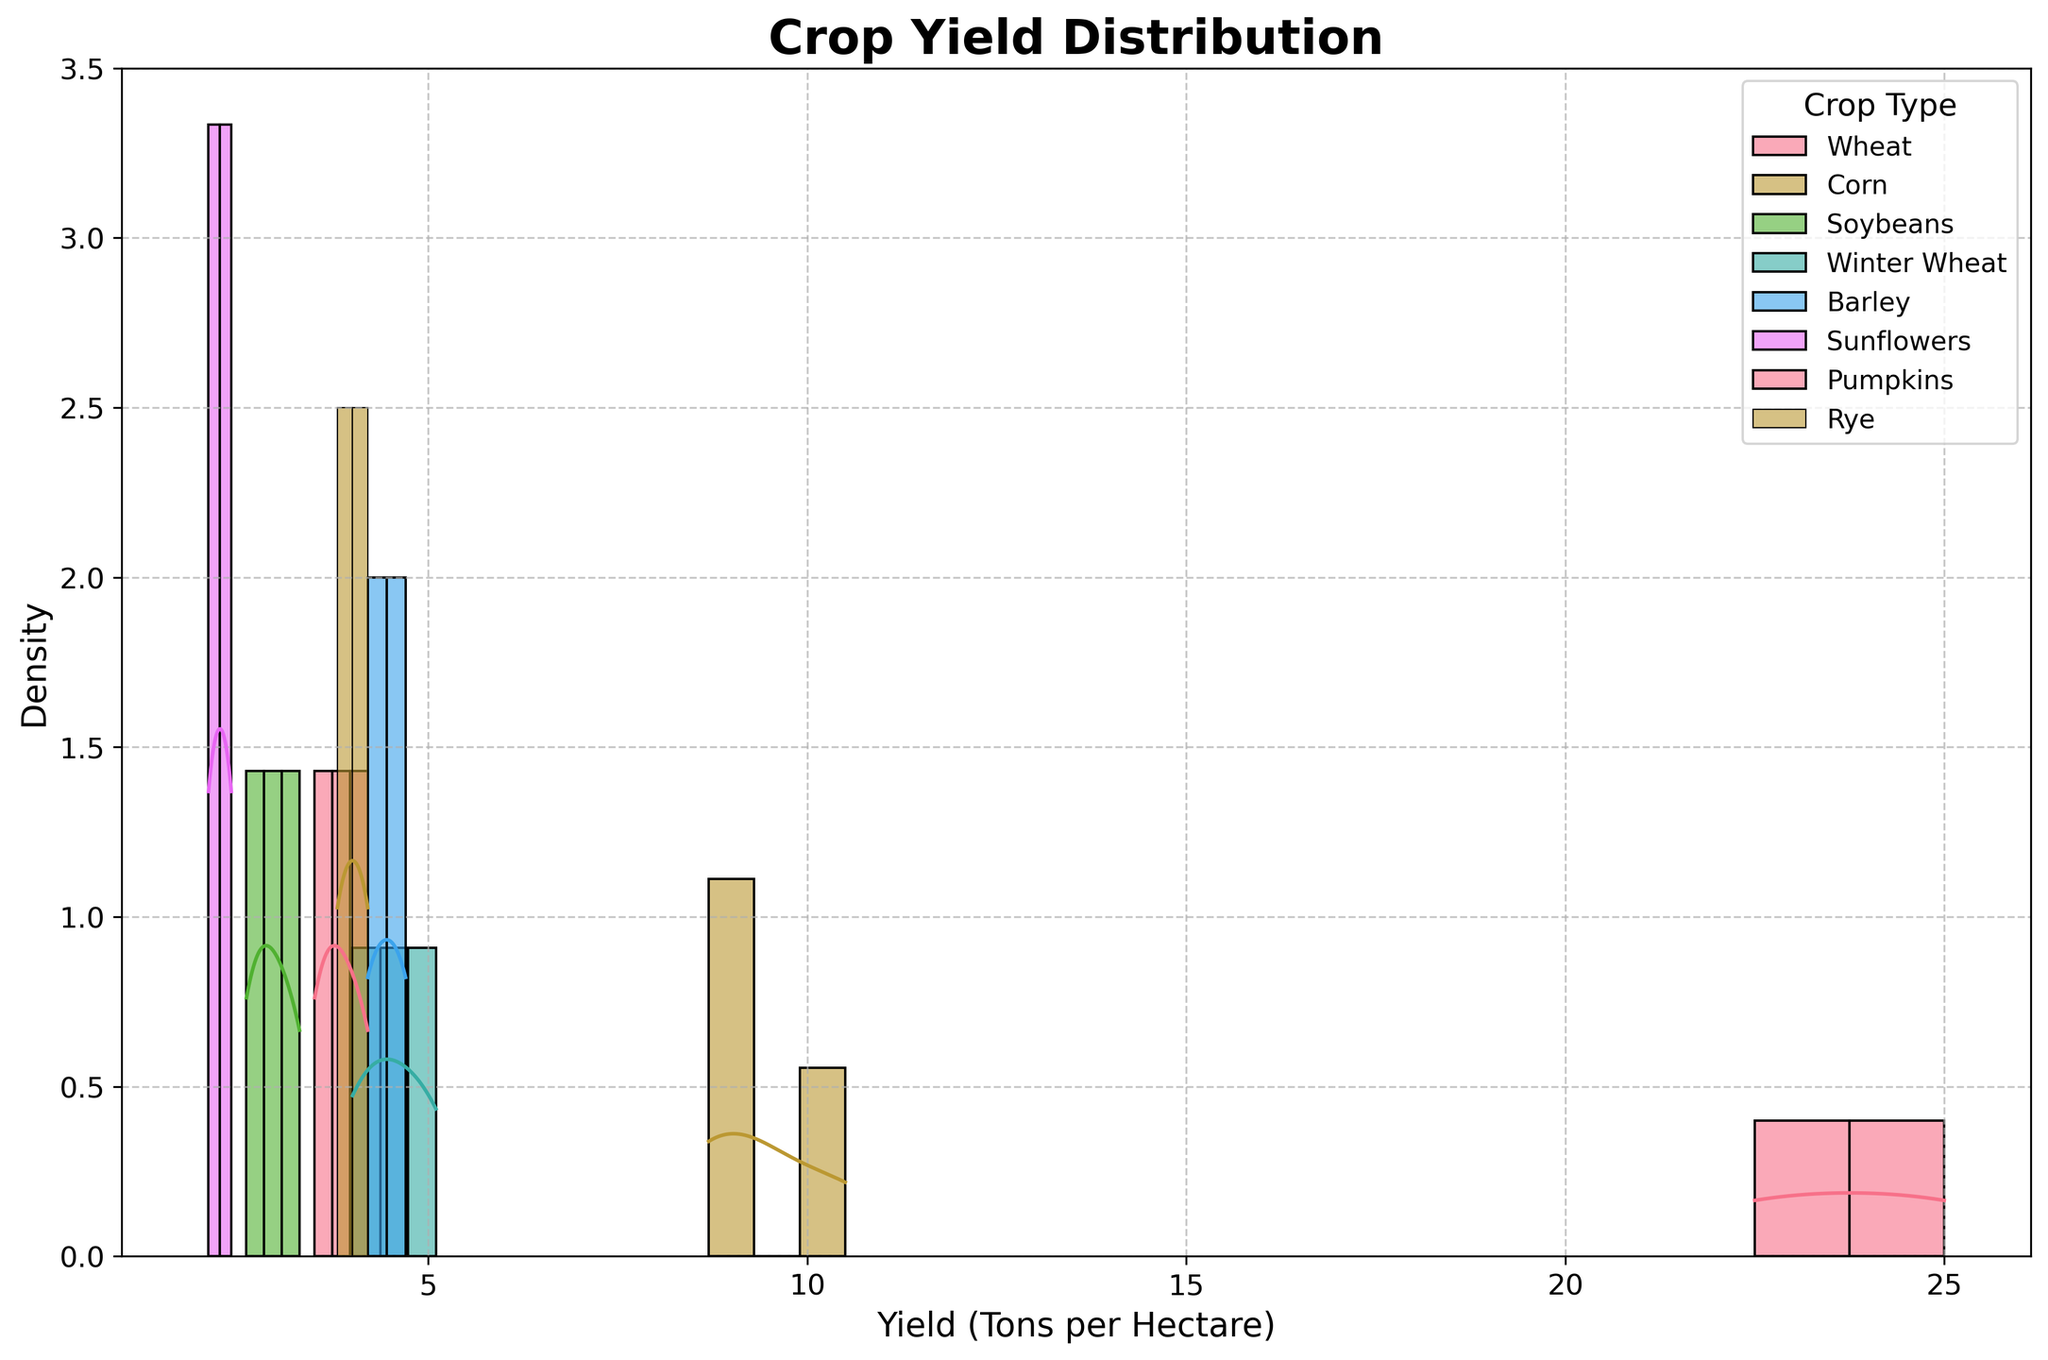What is the title of the figure? The title is typically displayed at the top of the figure, usually in larger or bold font to stand out. The title in this case is "Crop Yield Distribution", as mentioned in the code.
Answer: Crop Yield Distribution What does the x-axis represent? The x-axis usually represents the variable being measured or compared in the histogram. Here, it is labeled as "Yield (Tons per Hectare)" indicating it shows the yield in tons per hectare.
Answer: Yield (Tons per Hectare) Which crop has the highest peak density in yield? Look at the highest points of the density curves (KDE) of each crop. The crop with the highest peak (the tallest KDE curve) represents the one with the highest peak density in yield.
Answer: Pumpkins Which crop shows the widest range in yield distribution? Analyze the horizontal spread of the histogram and KDE for each crop. The one with the widest range of x-values represents the crop with the widest yield distribution.
Answer: Pumpkins How do the yields of Wheat in Spring compare to those of Corn in Summer? Compare the KDE curves and histograms for Wheat in Spring and Corn in Summer. Look for differences in peak yield, spread, and overall shape of distribution.
Answer: Corn in Summer tends to have higher yield Which crop has the most tightly clustered yields? Identify the KDE curve that is the narrowest and has the highest peak. This indicates that the yields do not vary much and are tightly clustered around a central value.
Answer: Winter Wheat What is the common yield range for Barley in Spring? Observe the histogram and KDE for Barley in Spring and identify the range along the x-axis where most of the data points are concentrated.
Answer: 4.2 to 4.7 tons per hectare How does the yield distribution of Soybeans in Fall differ from that of Winter Wheat in Winter? Compare the KDE and histogram shapes for Soybeans in Fall and Winter Wheat in Winter, noting differences in peak yield, spread, and overall shape.
Answer: Soybeans have a lower yield and wider spread Which crop experiences the most variability in yield under different weather conditions? Determine which crop has the most spread out KDE curve, indicating high variability in yield across different weather conditions.
Answer: Pumpkins 